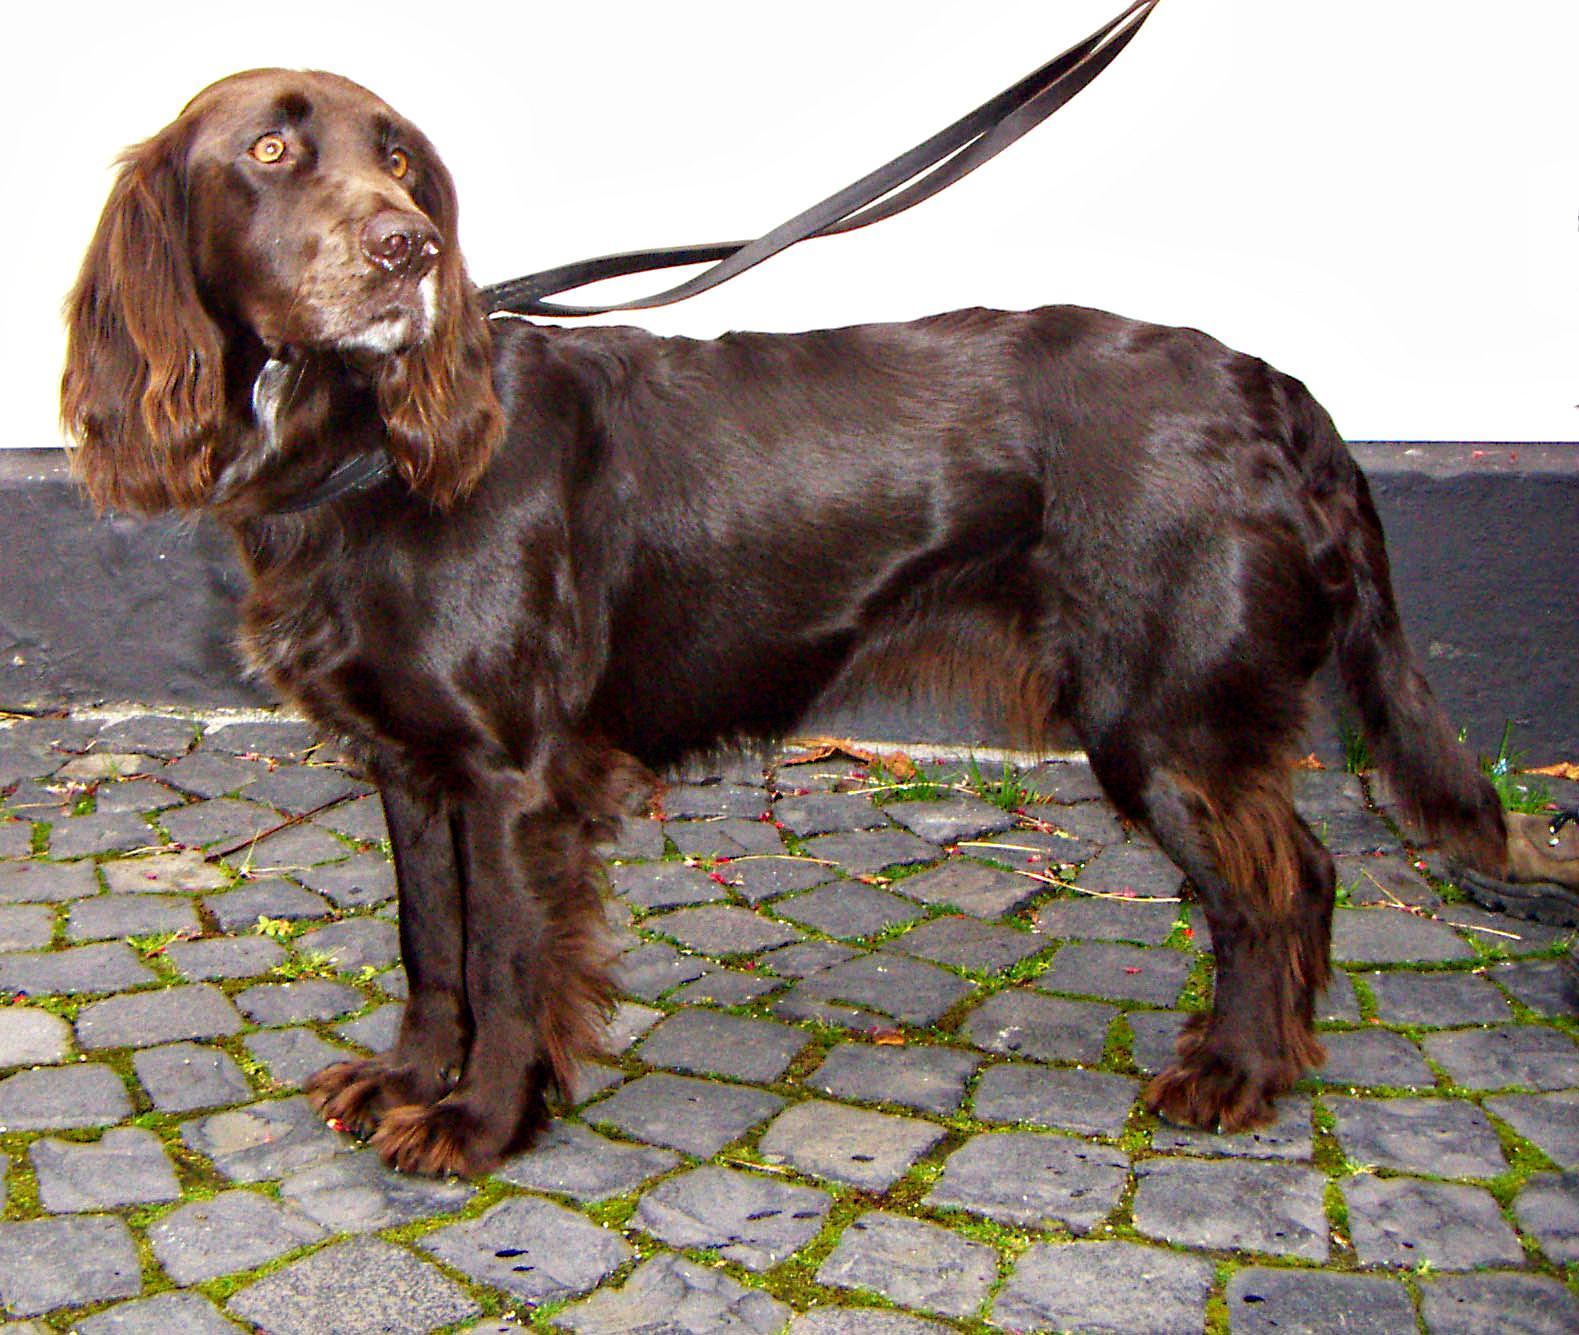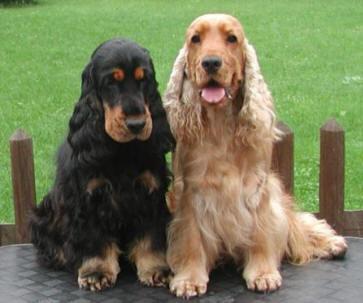The first image is the image on the left, the second image is the image on the right. For the images displayed, is the sentence "The left image contains one dog, a chocolate-brown spaniel with a leash extending from its neck." factually correct? Answer yes or no. Yes. The first image is the image on the left, the second image is the image on the right. For the images shown, is this caption "The dog in the image on the left is on a leash." true? Answer yes or no. Yes. 